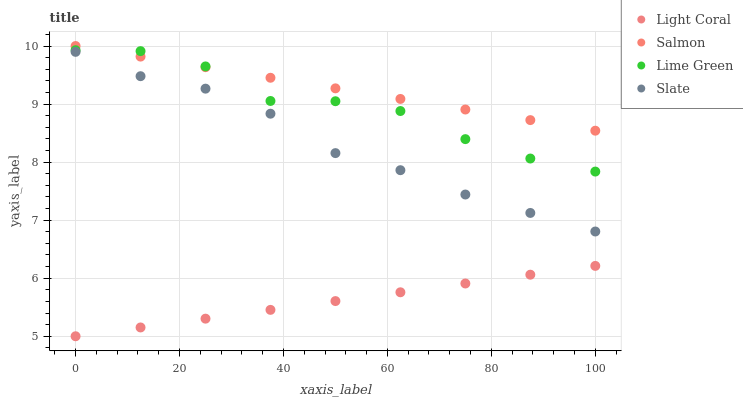Does Light Coral have the minimum area under the curve?
Answer yes or no. Yes. Does Salmon have the maximum area under the curve?
Answer yes or no. Yes. Does Lime Green have the minimum area under the curve?
Answer yes or no. No. Does Lime Green have the maximum area under the curve?
Answer yes or no. No. Is Light Coral the smoothest?
Answer yes or no. Yes. Is Lime Green the roughest?
Answer yes or no. Yes. Is Slate the smoothest?
Answer yes or no. No. Is Slate the roughest?
Answer yes or no. No. Does Light Coral have the lowest value?
Answer yes or no. Yes. Does Lime Green have the lowest value?
Answer yes or no. No. Does Salmon have the highest value?
Answer yes or no. Yes. Does Lime Green have the highest value?
Answer yes or no. No. Is Slate less than Salmon?
Answer yes or no. Yes. Is Lime Green greater than Slate?
Answer yes or no. Yes. Does Lime Green intersect Salmon?
Answer yes or no. Yes. Is Lime Green less than Salmon?
Answer yes or no. No. Is Lime Green greater than Salmon?
Answer yes or no. No. Does Slate intersect Salmon?
Answer yes or no. No. 